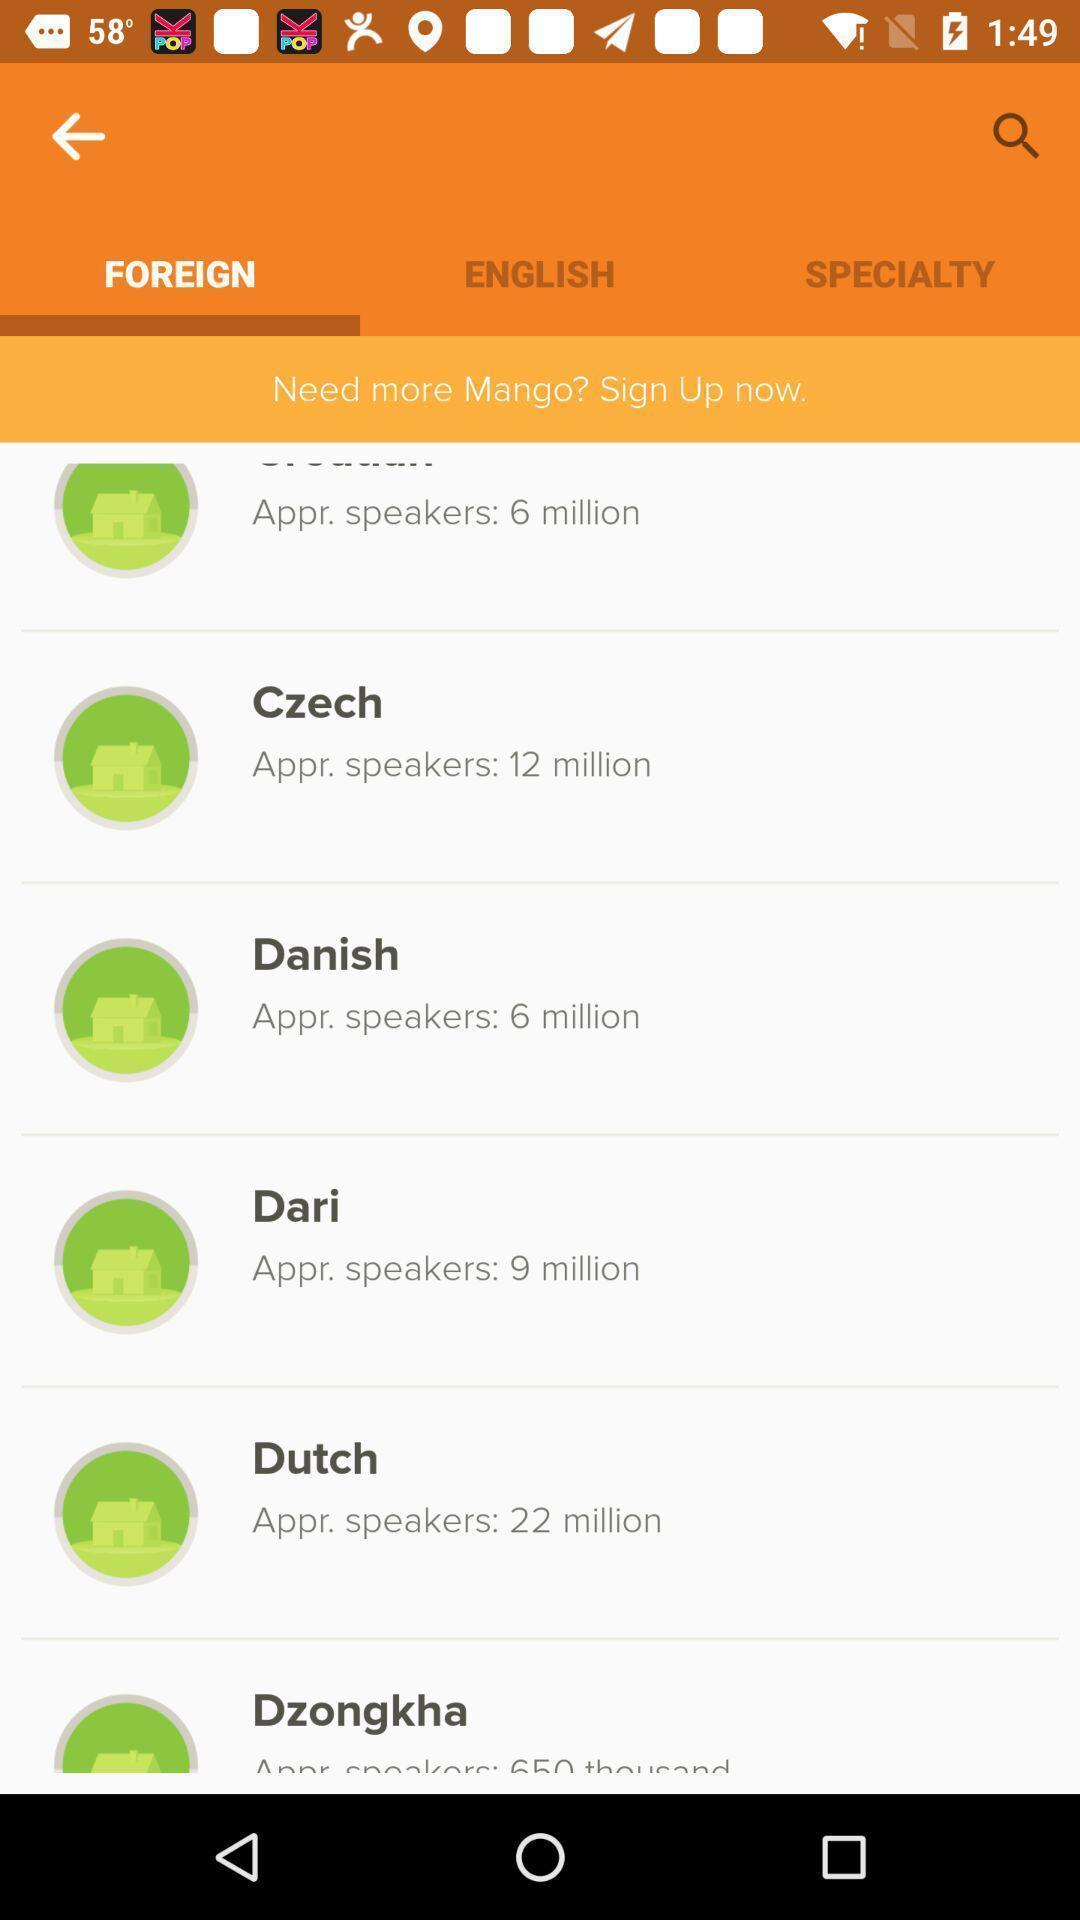What can you discern from this picture? Sign up page. 